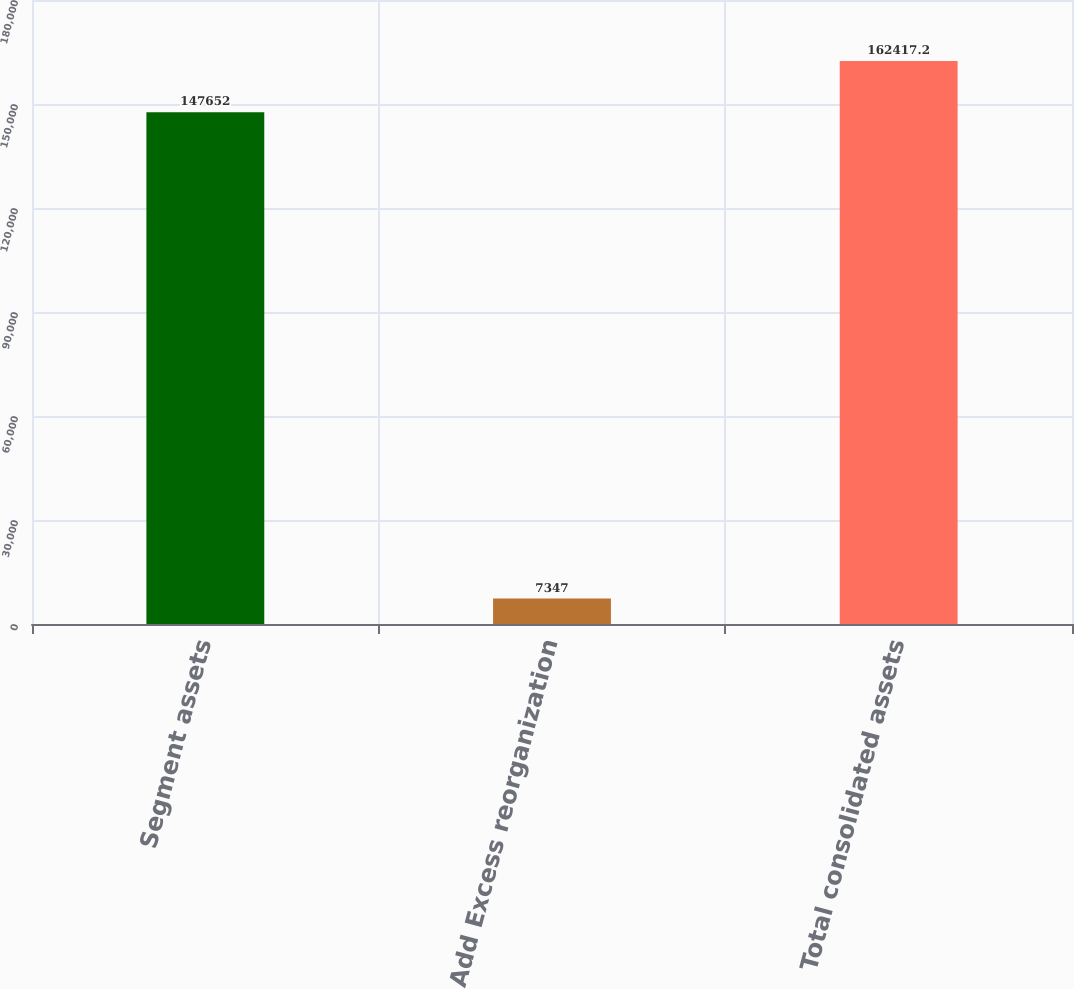Convert chart to OTSL. <chart><loc_0><loc_0><loc_500><loc_500><bar_chart><fcel>Segment assets<fcel>Add Excess reorganization<fcel>Total consolidated assets<nl><fcel>147652<fcel>7347<fcel>162417<nl></chart> 